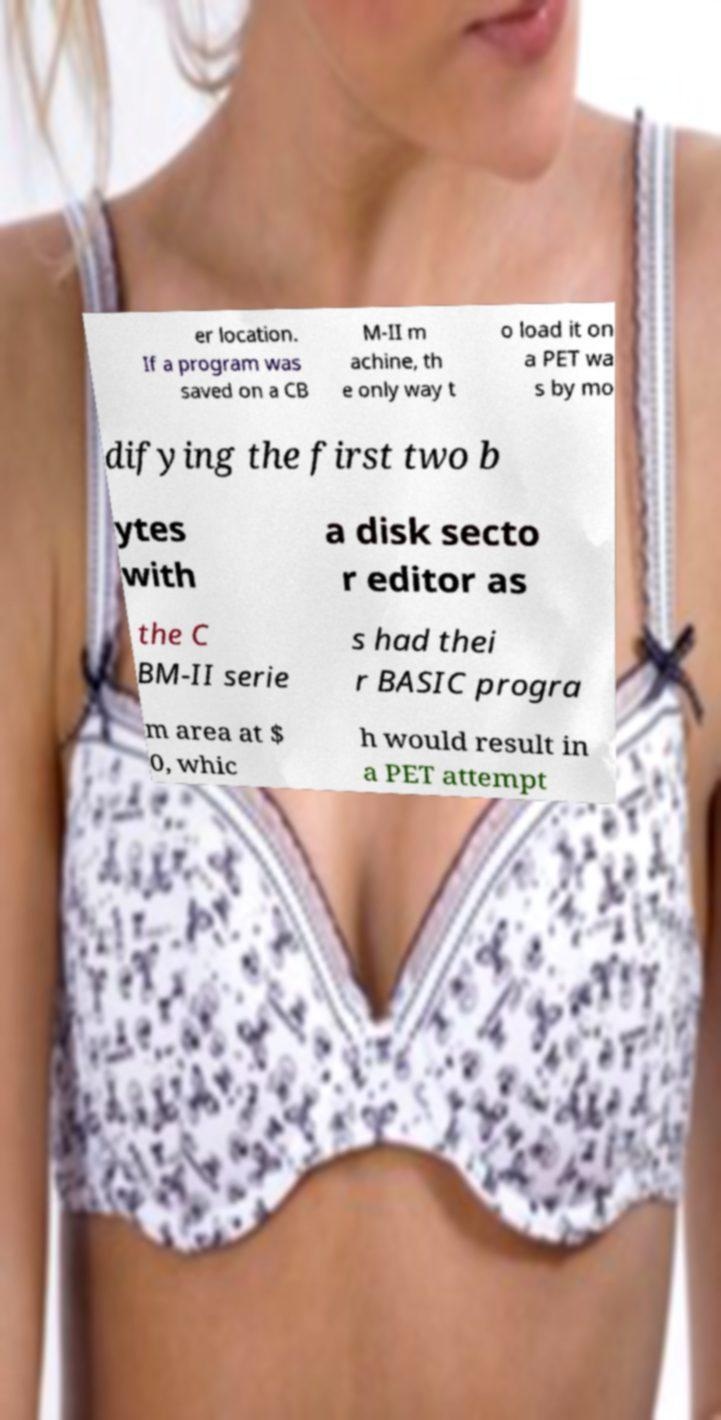What messages or text are displayed in this image? I need them in a readable, typed format. er location. If a program was saved on a CB M-II m achine, th e only way t o load it on a PET wa s by mo difying the first two b ytes with a disk secto r editor as the C BM-II serie s had thei r BASIC progra m area at $ 0, whic h would result in a PET attempt 